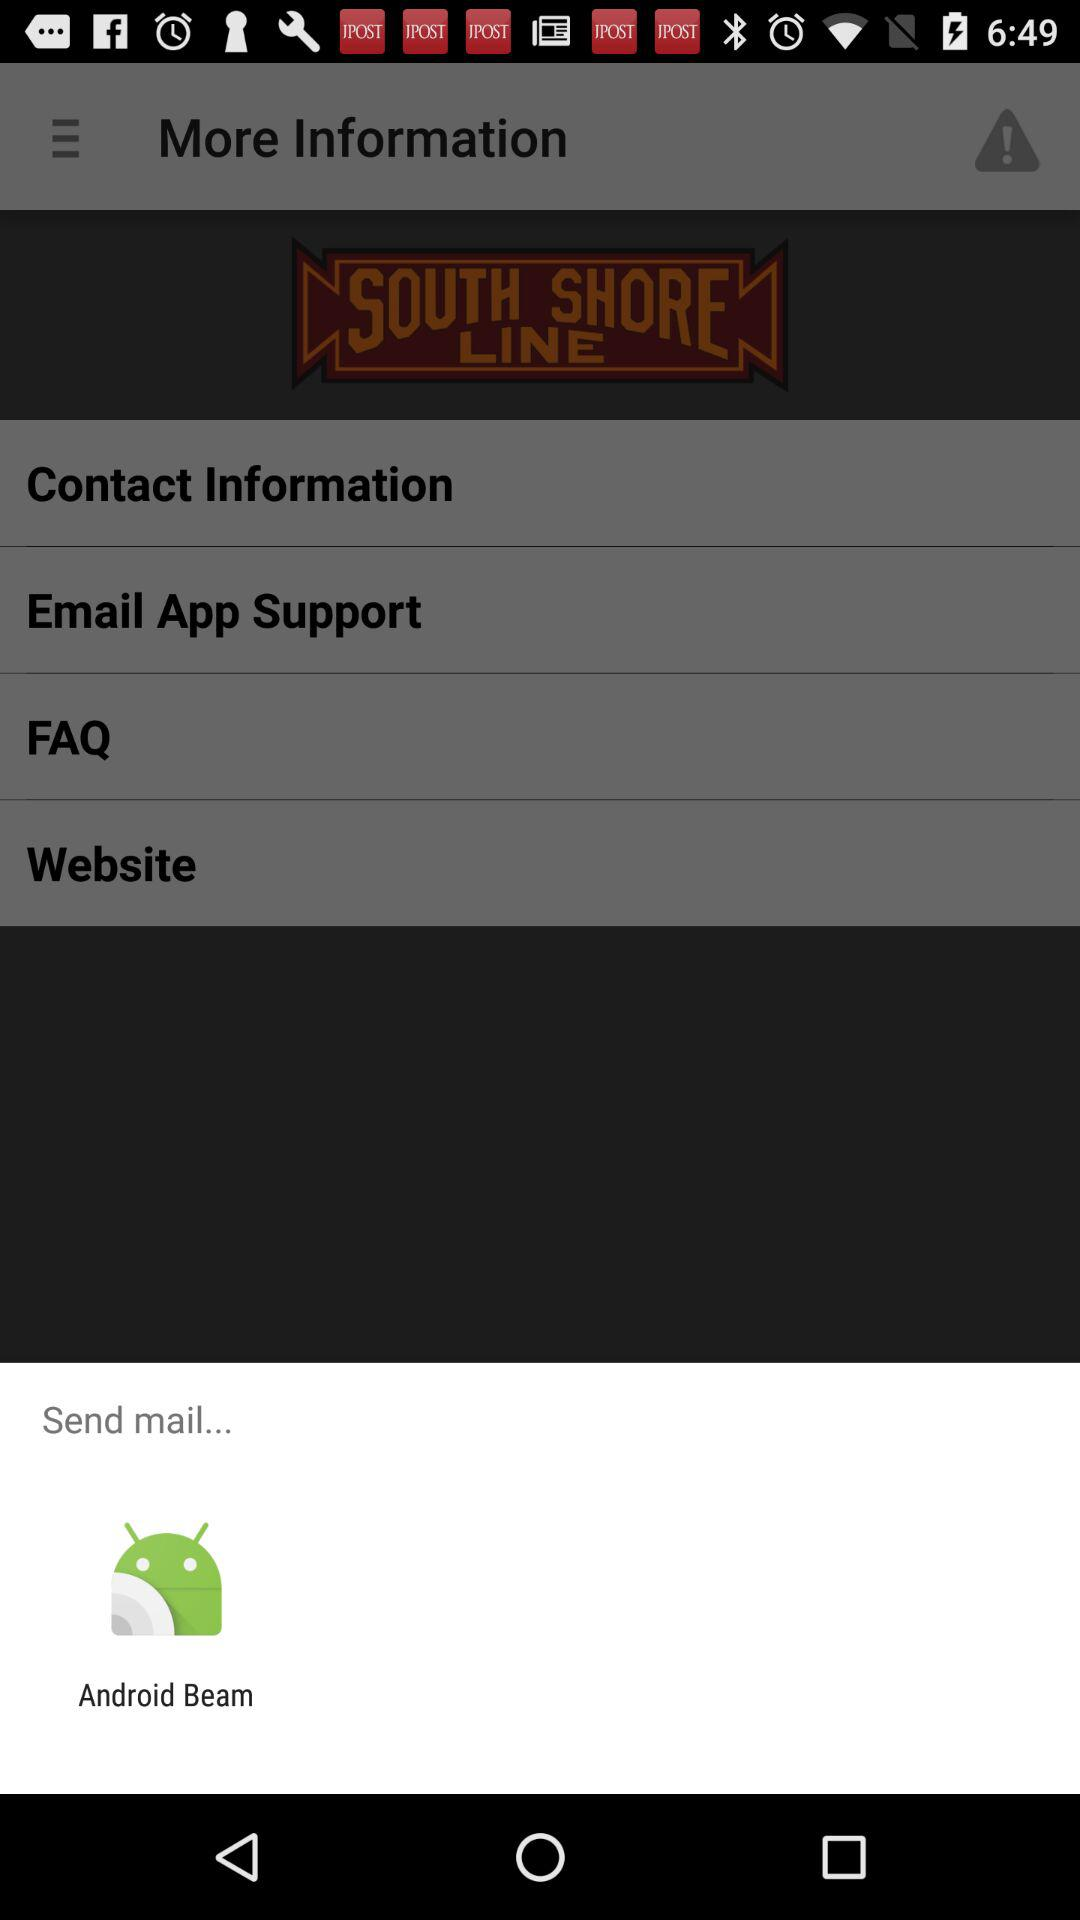Through what application can a user send the mail? The application is "Android Beam". 